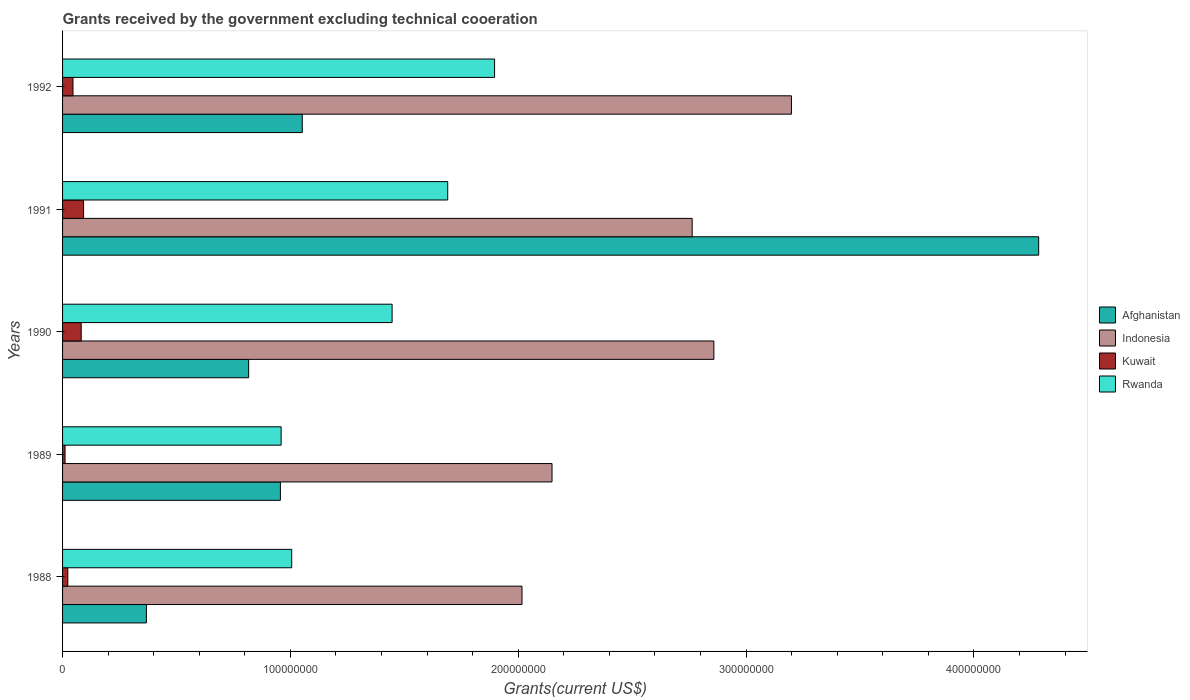How many groups of bars are there?
Your response must be concise. 5. Are the number of bars on each tick of the Y-axis equal?
Your response must be concise. Yes. How many bars are there on the 3rd tick from the top?
Give a very brief answer. 4. How many bars are there on the 4th tick from the bottom?
Keep it short and to the point. 4. What is the label of the 5th group of bars from the top?
Offer a terse response. 1988. What is the total grants received by the government in Rwanda in 1989?
Your answer should be very brief. 9.59e+07. Across all years, what is the maximum total grants received by the government in Kuwait?
Offer a terse response. 9.22e+06. Across all years, what is the minimum total grants received by the government in Afghanistan?
Make the answer very short. 3.68e+07. In which year was the total grants received by the government in Indonesia maximum?
Keep it short and to the point. 1992. In which year was the total grants received by the government in Afghanistan minimum?
Provide a short and direct response. 1988. What is the total total grants received by the government in Rwanda in the graph?
Offer a terse response. 7.00e+08. What is the difference between the total grants received by the government in Kuwait in 1988 and that in 1989?
Your response must be concise. 1.21e+06. What is the difference between the total grants received by the government in Kuwait in 1991 and the total grants received by the government in Rwanda in 1989?
Keep it short and to the point. -8.67e+07. What is the average total grants received by the government in Kuwait per year?
Provide a succinct answer. 5.07e+06. In the year 1990, what is the difference between the total grants received by the government in Afghanistan and total grants received by the government in Rwanda?
Give a very brief answer. -6.30e+07. In how many years, is the total grants received by the government in Afghanistan greater than 360000000 US$?
Offer a very short reply. 1. What is the ratio of the total grants received by the government in Rwanda in 1990 to that in 1992?
Offer a terse response. 0.76. Is the total grants received by the government in Kuwait in 1988 less than that in 1990?
Provide a short and direct response. Yes. What is the difference between the highest and the second highest total grants received by the government in Afghanistan?
Provide a succinct answer. 3.23e+08. What is the difference between the highest and the lowest total grants received by the government in Kuwait?
Your response must be concise. 8.13e+06. In how many years, is the total grants received by the government in Kuwait greater than the average total grants received by the government in Kuwait taken over all years?
Provide a succinct answer. 2. Is the sum of the total grants received by the government in Indonesia in 1990 and 1991 greater than the maximum total grants received by the government in Afghanistan across all years?
Give a very brief answer. Yes. What does the 2nd bar from the top in 1988 represents?
Your response must be concise. Kuwait. What does the 1st bar from the bottom in 1988 represents?
Give a very brief answer. Afghanistan. How many bars are there?
Provide a short and direct response. 20. Are all the bars in the graph horizontal?
Ensure brevity in your answer.  Yes. What is the difference between two consecutive major ticks on the X-axis?
Make the answer very short. 1.00e+08. Does the graph contain any zero values?
Your response must be concise. No. Does the graph contain grids?
Your answer should be compact. No. How many legend labels are there?
Offer a very short reply. 4. How are the legend labels stacked?
Keep it short and to the point. Vertical. What is the title of the graph?
Ensure brevity in your answer.  Grants received by the government excluding technical cooeration. Does "Yemen, Rep." appear as one of the legend labels in the graph?
Ensure brevity in your answer.  No. What is the label or title of the X-axis?
Your answer should be very brief. Grants(current US$). What is the label or title of the Y-axis?
Ensure brevity in your answer.  Years. What is the Grants(current US$) in Afghanistan in 1988?
Your response must be concise. 3.68e+07. What is the Grants(current US$) in Indonesia in 1988?
Offer a very short reply. 2.02e+08. What is the Grants(current US$) in Kuwait in 1988?
Provide a short and direct response. 2.30e+06. What is the Grants(current US$) of Rwanda in 1988?
Offer a very short reply. 1.01e+08. What is the Grants(current US$) in Afghanistan in 1989?
Make the answer very short. 9.56e+07. What is the Grants(current US$) of Indonesia in 1989?
Make the answer very short. 2.15e+08. What is the Grants(current US$) of Kuwait in 1989?
Make the answer very short. 1.09e+06. What is the Grants(current US$) in Rwanda in 1989?
Keep it short and to the point. 9.59e+07. What is the Grants(current US$) in Afghanistan in 1990?
Ensure brevity in your answer.  8.17e+07. What is the Grants(current US$) of Indonesia in 1990?
Keep it short and to the point. 2.86e+08. What is the Grants(current US$) in Kuwait in 1990?
Keep it short and to the point. 8.18e+06. What is the Grants(current US$) of Rwanda in 1990?
Make the answer very short. 1.45e+08. What is the Grants(current US$) in Afghanistan in 1991?
Provide a short and direct response. 4.28e+08. What is the Grants(current US$) of Indonesia in 1991?
Keep it short and to the point. 2.76e+08. What is the Grants(current US$) in Kuwait in 1991?
Provide a succinct answer. 9.22e+06. What is the Grants(current US$) of Rwanda in 1991?
Your response must be concise. 1.69e+08. What is the Grants(current US$) of Afghanistan in 1992?
Ensure brevity in your answer.  1.05e+08. What is the Grants(current US$) of Indonesia in 1992?
Your answer should be very brief. 3.20e+08. What is the Grants(current US$) in Kuwait in 1992?
Keep it short and to the point. 4.57e+06. What is the Grants(current US$) of Rwanda in 1992?
Keep it short and to the point. 1.90e+08. Across all years, what is the maximum Grants(current US$) in Afghanistan?
Give a very brief answer. 4.28e+08. Across all years, what is the maximum Grants(current US$) in Indonesia?
Provide a succinct answer. 3.20e+08. Across all years, what is the maximum Grants(current US$) of Kuwait?
Make the answer very short. 9.22e+06. Across all years, what is the maximum Grants(current US$) in Rwanda?
Your response must be concise. 1.90e+08. Across all years, what is the minimum Grants(current US$) of Afghanistan?
Your response must be concise. 3.68e+07. Across all years, what is the minimum Grants(current US$) in Indonesia?
Your answer should be very brief. 2.02e+08. Across all years, what is the minimum Grants(current US$) in Kuwait?
Your response must be concise. 1.09e+06. Across all years, what is the minimum Grants(current US$) of Rwanda?
Your response must be concise. 9.59e+07. What is the total Grants(current US$) of Afghanistan in the graph?
Give a very brief answer. 7.48e+08. What is the total Grants(current US$) of Indonesia in the graph?
Make the answer very short. 1.30e+09. What is the total Grants(current US$) of Kuwait in the graph?
Your answer should be very brief. 2.54e+07. What is the total Grants(current US$) in Rwanda in the graph?
Your response must be concise. 7.00e+08. What is the difference between the Grants(current US$) of Afghanistan in 1988 and that in 1989?
Offer a very short reply. -5.88e+07. What is the difference between the Grants(current US$) of Indonesia in 1988 and that in 1989?
Keep it short and to the point. -1.32e+07. What is the difference between the Grants(current US$) of Kuwait in 1988 and that in 1989?
Give a very brief answer. 1.21e+06. What is the difference between the Grants(current US$) of Rwanda in 1988 and that in 1989?
Your answer should be compact. 4.64e+06. What is the difference between the Grants(current US$) in Afghanistan in 1988 and that in 1990?
Offer a terse response. -4.49e+07. What is the difference between the Grants(current US$) of Indonesia in 1988 and that in 1990?
Your answer should be compact. -8.42e+07. What is the difference between the Grants(current US$) in Kuwait in 1988 and that in 1990?
Keep it short and to the point. -5.88e+06. What is the difference between the Grants(current US$) in Rwanda in 1988 and that in 1990?
Keep it short and to the point. -4.41e+07. What is the difference between the Grants(current US$) in Afghanistan in 1988 and that in 1991?
Your answer should be compact. -3.92e+08. What is the difference between the Grants(current US$) in Indonesia in 1988 and that in 1991?
Your answer should be very brief. -7.47e+07. What is the difference between the Grants(current US$) of Kuwait in 1988 and that in 1991?
Provide a short and direct response. -6.92e+06. What is the difference between the Grants(current US$) in Rwanda in 1988 and that in 1991?
Your response must be concise. -6.85e+07. What is the difference between the Grants(current US$) of Afghanistan in 1988 and that in 1992?
Provide a succinct answer. -6.84e+07. What is the difference between the Grants(current US$) of Indonesia in 1988 and that in 1992?
Provide a succinct answer. -1.18e+08. What is the difference between the Grants(current US$) of Kuwait in 1988 and that in 1992?
Provide a succinct answer. -2.27e+06. What is the difference between the Grants(current US$) in Rwanda in 1988 and that in 1992?
Your response must be concise. -8.90e+07. What is the difference between the Grants(current US$) of Afghanistan in 1989 and that in 1990?
Provide a short and direct response. 1.39e+07. What is the difference between the Grants(current US$) of Indonesia in 1989 and that in 1990?
Give a very brief answer. -7.10e+07. What is the difference between the Grants(current US$) in Kuwait in 1989 and that in 1990?
Offer a terse response. -7.09e+06. What is the difference between the Grants(current US$) in Rwanda in 1989 and that in 1990?
Offer a very short reply. -4.87e+07. What is the difference between the Grants(current US$) in Afghanistan in 1989 and that in 1991?
Your answer should be very brief. -3.33e+08. What is the difference between the Grants(current US$) of Indonesia in 1989 and that in 1991?
Provide a succinct answer. -6.15e+07. What is the difference between the Grants(current US$) of Kuwait in 1989 and that in 1991?
Provide a short and direct response. -8.13e+06. What is the difference between the Grants(current US$) in Rwanda in 1989 and that in 1991?
Make the answer very short. -7.31e+07. What is the difference between the Grants(current US$) of Afghanistan in 1989 and that in 1992?
Offer a terse response. -9.60e+06. What is the difference between the Grants(current US$) of Indonesia in 1989 and that in 1992?
Make the answer very short. -1.05e+08. What is the difference between the Grants(current US$) in Kuwait in 1989 and that in 1992?
Offer a terse response. -3.48e+06. What is the difference between the Grants(current US$) of Rwanda in 1989 and that in 1992?
Your answer should be compact. -9.37e+07. What is the difference between the Grants(current US$) of Afghanistan in 1990 and that in 1991?
Your answer should be very brief. -3.47e+08. What is the difference between the Grants(current US$) in Indonesia in 1990 and that in 1991?
Offer a very short reply. 9.52e+06. What is the difference between the Grants(current US$) of Kuwait in 1990 and that in 1991?
Your answer should be very brief. -1.04e+06. What is the difference between the Grants(current US$) in Rwanda in 1990 and that in 1991?
Provide a short and direct response. -2.44e+07. What is the difference between the Grants(current US$) in Afghanistan in 1990 and that in 1992?
Your answer should be very brief. -2.35e+07. What is the difference between the Grants(current US$) of Indonesia in 1990 and that in 1992?
Offer a terse response. -3.40e+07. What is the difference between the Grants(current US$) in Kuwait in 1990 and that in 1992?
Provide a succinct answer. 3.61e+06. What is the difference between the Grants(current US$) in Rwanda in 1990 and that in 1992?
Provide a succinct answer. -4.50e+07. What is the difference between the Grants(current US$) of Afghanistan in 1991 and that in 1992?
Offer a terse response. 3.23e+08. What is the difference between the Grants(current US$) of Indonesia in 1991 and that in 1992?
Your response must be concise. -4.36e+07. What is the difference between the Grants(current US$) in Kuwait in 1991 and that in 1992?
Provide a succinct answer. 4.65e+06. What is the difference between the Grants(current US$) of Rwanda in 1991 and that in 1992?
Provide a short and direct response. -2.06e+07. What is the difference between the Grants(current US$) of Afghanistan in 1988 and the Grants(current US$) of Indonesia in 1989?
Provide a short and direct response. -1.78e+08. What is the difference between the Grants(current US$) of Afghanistan in 1988 and the Grants(current US$) of Kuwait in 1989?
Give a very brief answer. 3.57e+07. What is the difference between the Grants(current US$) of Afghanistan in 1988 and the Grants(current US$) of Rwanda in 1989?
Make the answer very short. -5.91e+07. What is the difference between the Grants(current US$) of Indonesia in 1988 and the Grants(current US$) of Kuwait in 1989?
Provide a short and direct response. 2.01e+08. What is the difference between the Grants(current US$) in Indonesia in 1988 and the Grants(current US$) in Rwanda in 1989?
Provide a short and direct response. 1.06e+08. What is the difference between the Grants(current US$) of Kuwait in 1988 and the Grants(current US$) of Rwanda in 1989?
Your answer should be very brief. -9.36e+07. What is the difference between the Grants(current US$) of Afghanistan in 1988 and the Grants(current US$) of Indonesia in 1990?
Your response must be concise. -2.49e+08. What is the difference between the Grants(current US$) in Afghanistan in 1988 and the Grants(current US$) in Kuwait in 1990?
Keep it short and to the point. 2.86e+07. What is the difference between the Grants(current US$) in Afghanistan in 1988 and the Grants(current US$) in Rwanda in 1990?
Offer a terse response. -1.08e+08. What is the difference between the Grants(current US$) in Indonesia in 1988 and the Grants(current US$) in Kuwait in 1990?
Ensure brevity in your answer.  1.93e+08. What is the difference between the Grants(current US$) in Indonesia in 1988 and the Grants(current US$) in Rwanda in 1990?
Make the answer very short. 5.70e+07. What is the difference between the Grants(current US$) in Kuwait in 1988 and the Grants(current US$) in Rwanda in 1990?
Keep it short and to the point. -1.42e+08. What is the difference between the Grants(current US$) of Afghanistan in 1988 and the Grants(current US$) of Indonesia in 1991?
Your answer should be very brief. -2.40e+08. What is the difference between the Grants(current US$) in Afghanistan in 1988 and the Grants(current US$) in Kuwait in 1991?
Keep it short and to the point. 2.76e+07. What is the difference between the Grants(current US$) in Afghanistan in 1988 and the Grants(current US$) in Rwanda in 1991?
Your answer should be compact. -1.32e+08. What is the difference between the Grants(current US$) of Indonesia in 1988 and the Grants(current US$) of Kuwait in 1991?
Provide a short and direct response. 1.92e+08. What is the difference between the Grants(current US$) in Indonesia in 1988 and the Grants(current US$) in Rwanda in 1991?
Your answer should be very brief. 3.26e+07. What is the difference between the Grants(current US$) of Kuwait in 1988 and the Grants(current US$) of Rwanda in 1991?
Give a very brief answer. -1.67e+08. What is the difference between the Grants(current US$) in Afghanistan in 1988 and the Grants(current US$) in Indonesia in 1992?
Offer a very short reply. -2.83e+08. What is the difference between the Grants(current US$) in Afghanistan in 1988 and the Grants(current US$) in Kuwait in 1992?
Keep it short and to the point. 3.22e+07. What is the difference between the Grants(current US$) in Afghanistan in 1988 and the Grants(current US$) in Rwanda in 1992?
Your answer should be compact. -1.53e+08. What is the difference between the Grants(current US$) in Indonesia in 1988 and the Grants(current US$) in Kuwait in 1992?
Offer a terse response. 1.97e+08. What is the difference between the Grants(current US$) of Indonesia in 1988 and the Grants(current US$) of Rwanda in 1992?
Your answer should be very brief. 1.20e+07. What is the difference between the Grants(current US$) in Kuwait in 1988 and the Grants(current US$) in Rwanda in 1992?
Your answer should be compact. -1.87e+08. What is the difference between the Grants(current US$) of Afghanistan in 1989 and the Grants(current US$) of Indonesia in 1990?
Your response must be concise. -1.90e+08. What is the difference between the Grants(current US$) of Afghanistan in 1989 and the Grants(current US$) of Kuwait in 1990?
Your response must be concise. 8.74e+07. What is the difference between the Grants(current US$) of Afghanistan in 1989 and the Grants(current US$) of Rwanda in 1990?
Ensure brevity in your answer.  -4.90e+07. What is the difference between the Grants(current US$) in Indonesia in 1989 and the Grants(current US$) in Kuwait in 1990?
Provide a short and direct response. 2.07e+08. What is the difference between the Grants(current US$) of Indonesia in 1989 and the Grants(current US$) of Rwanda in 1990?
Ensure brevity in your answer.  7.02e+07. What is the difference between the Grants(current US$) in Kuwait in 1989 and the Grants(current US$) in Rwanda in 1990?
Make the answer very short. -1.44e+08. What is the difference between the Grants(current US$) of Afghanistan in 1989 and the Grants(current US$) of Indonesia in 1991?
Your answer should be very brief. -1.81e+08. What is the difference between the Grants(current US$) in Afghanistan in 1989 and the Grants(current US$) in Kuwait in 1991?
Make the answer very short. 8.64e+07. What is the difference between the Grants(current US$) in Afghanistan in 1989 and the Grants(current US$) in Rwanda in 1991?
Your answer should be compact. -7.34e+07. What is the difference between the Grants(current US$) in Indonesia in 1989 and the Grants(current US$) in Kuwait in 1991?
Give a very brief answer. 2.06e+08. What is the difference between the Grants(current US$) of Indonesia in 1989 and the Grants(current US$) of Rwanda in 1991?
Offer a terse response. 4.58e+07. What is the difference between the Grants(current US$) of Kuwait in 1989 and the Grants(current US$) of Rwanda in 1991?
Offer a terse response. -1.68e+08. What is the difference between the Grants(current US$) of Afghanistan in 1989 and the Grants(current US$) of Indonesia in 1992?
Your answer should be very brief. -2.24e+08. What is the difference between the Grants(current US$) in Afghanistan in 1989 and the Grants(current US$) in Kuwait in 1992?
Give a very brief answer. 9.10e+07. What is the difference between the Grants(current US$) in Afghanistan in 1989 and the Grants(current US$) in Rwanda in 1992?
Your answer should be compact. -9.40e+07. What is the difference between the Grants(current US$) of Indonesia in 1989 and the Grants(current US$) of Kuwait in 1992?
Ensure brevity in your answer.  2.10e+08. What is the difference between the Grants(current US$) in Indonesia in 1989 and the Grants(current US$) in Rwanda in 1992?
Keep it short and to the point. 2.52e+07. What is the difference between the Grants(current US$) in Kuwait in 1989 and the Grants(current US$) in Rwanda in 1992?
Keep it short and to the point. -1.89e+08. What is the difference between the Grants(current US$) in Afghanistan in 1990 and the Grants(current US$) in Indonesia in 1991?
Make the answer very short. -1.95e+08. What is the difference between the Grants(current US$) in Afghanistan in 1990 and the Grants(current US$) in Kuwait in 1991?
Offer a terse response. 7.25e+07. What is the difference between the Grants(current US$) of Afghanistan in 1990 and the Grants(current US$) of Rwanda in 1991?
Ensure brevity in your answer.  -8.74e+07. What is the difference between the Grants(current US$) of Indonesia in 1990 and the Grants(current US$) of Kuwait in 1991?
Offer a very short reply. 2.77e+08. What is the difference between the Grants(current US$) of Indonesia in 1990 and the Grants(current US$) of Rwanda in 1991?
Your answer should be compact. 1.17e+08. What is the difference between the Grants(current US$) in Kuwait in 1990 and the Grants(current US$) in Rwanda in 1991?
Provide a short and direct response. -1.61e+08. What is the difference between the Grants(current US$) in Afghanistan in 1990 and the Grants(current US$) in Indonesia in 1992?
Your answer should be compact. -2.38e+08. What is the difference between the Grants(current US$) in Afghanistan in 1990 and the Grants(current US$) in Kuwait in 1992?
Provide a short and direct response. 7.71e+07. What is the difference between the Grants(current US$) of Afghanistan in 1990 and the Grants(current US$) of Rwanda in 1992?
Provide a short and direct response. -1.08e+08. What is the difference between the Grants(current US$) in Indonesia in 1990 and the Grants(current US$) in Kuwait in 1992?
Your answer should be very brief. 2.81e+08. What is the difference between the Grants(current US$) of Indonesia in 1990 and the Grants(current US$) of Rwanda in 1992?
Your response must be concise. 9.62e+07. What is the difference between the Grants(current US$) of Kuwait in 1990 and the Grants(current US$) of Rwanda in 1992?
Your answer should be very brief. -1.81e+08. What is the difference between the Grants(current US$) of Afghanistan in 1991 and the Grants(current US$) of Indonesia in 1992?
Provide a short and direct response. 1.09e+08. What is the difference between the Grants(current US$) in Afghanistan in 1991 and the Grants(current US$) in Kuwait in 1992?
Offer a very short reply. 4.24e+08. What is the difference between the Grants(current US$) of Afghanistan in 1991 and the Grants(current US$) of Rwanda in 1992?
Ensure brevity in your answer.  2.39e+08. What is the difference between the Grants(current US$) in Indonesia in 1991 and the Grants(current US$) in Kuwait in 1992?
Your answer should be compact. 2.72e+08. What is the difference between the Grants(current US$) in Indonesia in 1991 and the Grants(current US$) in Rwanda in 1992?
Make the answer very short. 8.67e+07. What is the difference between the Grants(current US$) in Kuwait in 1991 and the Grants(current US$) in Rwanda in 1992?
Make the answer very short. -1.80e+08. What is the average Grants(current US$) of Afghanistan per year?
Your answer should be very brief. 1.50e+08. What is the average Grants(current US$) of Indonesia per year?
Give a very brief answer. 2.60e+08. What is the average Grants(current US$) of Kuwait per year?
Offer a terse response. 5.07e+06. What is the average Grants(current US$) in Rwanda per year?
Your response must be concise. 1.40e+08. In the year 1988, what is the difference between the Grants(current US$) of Afghanistan and Grants(current US$) of Indonesia?
Keep it short and to the point. -1.65e+08. In the year 1988, what is the difference between the Grants(current US$) in Afghanistan and Grants(current US$) in Kuwait?
Keep it short and to the point. 3.45e+07. In the year 1988, what is the difference between the Grants(current US$) in Afghanistan and Grants(current US$) in Rwanda?
Offer a terse response. -6.38e+07. In the year 1988, what is the difference between the Grants(current US$) in Indonesia and Grants(current US$) in Kuwait?
Your response must be concise. 1.99e+08. In the year 1988, what is the difference between the Grants(current US$) of Indonesia and Grants(current US$) of Rwanda?
Your response must be concise. 1.01e+08. In the year 1988, what is the difference between the Grants(current US$) of Kuwait and Grants(current US$) of Rwanda?
Give a very brief answer. -9.83e+07. In the year 1989, what is the difference between the Grants(current US$) in Afghanistan and Grants(current US$) in Indonesia?
Make the answer very short. -1.19e+08. In the year 1989, what is the difference between the Grants(current US$) in Afghanistan and Grants(current US$) in Kuwait?
Make the answer very short. 9.45e+07. In the year 1989, what is the difference between the Grants(current US$) in Afghanistan and Grants(current US$) in Rwanda?
Keep it short and to the point. -3.20e+05. In the year 1989, what is the difference between the Grants(current US$) of Indonesia and Grants(current US$) of Kuwait?
Make the answer very short. 2.14e+08. In the year 1989, what is the difference between the Grants(current US$) of Indonesia and Grants(current US$) of Rwanda?
Offer a terse response. 1.19e+08. In the year 1989, what is the difference between the Grants(current US$) in Kuwait and Grants(current US$) in Rwanda?
Offer a very short reply. -9.48e+07. In the year 1990, what is the difference between the Grants(current US$) of Afghanistan and Grants(current US$) of Indonesia?
Ensure brevity in your answer.  -2.04e+08. In the year 1990, what is the difference between the Grants(current US$) in Afghanistan and Grants(current US$) in Kuwait?
Your response must be concise. 7.35e+07. In the year 1990, what is the difference between the Grants(current US$) in Afghanistan and Grants(current US$) in Rwanda?
Your response must be concise. -6.30e+07. In the year 1990, what is the difference between the Grants(current US$) in Indonesia and Grants(current US$) in Kuwait?
Your response must be concise. 2.78e+08. In the year 1990, what is the difference between the Grants(current US$) of Indonesia and Grants(current US$) of Rwanda?
Provide a succinct answer. 1.41e+08. In the year 1990, what is the difference between the Grants(current US$) of Kuwait and Grants(current US$) of Rwanda?
Ensure brevity in your answer.  -1.36e+08. In the year 1991, what is the difference between the Grants(current US$) of Afghanistan and Grants(current US$) of Indonesia?
Offer a very short reply. 1.52e+08. In the year 1991, what is the difference between the Grants(current US$) in Afghanistan and Grants(current US$) in Kuwait?
Your response must be concise. 4.19e+08. In the year 1991, what is the difference between the Grants(current US$) in Afghanistan and Grants(current US$) in Rwanda?
Give a very brief answer. 2.59e+08. In the year 1991, what is the difference between the Grants(current US$) of Indonesia and Grants(current US$) of Kuwait?
Ensure brevity in your answer.  2.67e+08. In the year 1991, what is the difference between the Grants(current US$) in Indonesia and Grants(current US$) in Rwanda?
Offer a terse response. 1.07e+08. In the year 1991, what is the difference between the Grants(current US$) in Kuwait and Grants(current US$) in Rwanda?
Offer a very short reply. -1.60e+08. In the year 1992, what is the difference between the Grants(current US$) of Afghanistan and Grants(current US$) of Indonesia?
Make the answer very short. -2.15e+08. In the year 1992, what is the difference between the Grants(current US$) in Afghanistan and Grants(current US$) in Kuwait?
Make the answer very short. 1.01e+08. In the year 1992, what is the difference between the Grants(current US$) of Afghanistan and Grants(current US$) of Rwanda?
Your answer should be very brief. -8.44e+07. In the year 1992, what is the difference between the Grants(current US$) of Indonesia and Grants(current US$) of Kuwait?
Make the answer very short. 3.15e+08. In the year 1992, what is the difference between the Grants(current US$) in Indonesia and Grants(current US$) in Rwanda?
Provide a succinct answer. 1.30e+08. In the year 1992, what is the difference between the Grants(current US$) of Kuwait and Grants(current US$) of Rwanda?
Make the answer very short. -1.85e+08. What is the ratio of the Grants(current US$) in Afghanistan in 1988 to that in 1989?
Ensure brevity in your answer.  0.38. What is the ratio of the Grants(current US$) of Indonesia in 1988 to that in 1989?
Offer a terse response. 0.94. What is the ratio of the Grants(current US$) of Kuwait in 1988 to that in 1989?
Keep it short and to the point. 2.11. What is the ratio of the Grants(current US$) of Rwanda in 1988 to that in 1989?
Ensure brevity in your answer.  1.05. What is the ratio of the Grants(current US$) in Afghanistan in 1988 to that in 1990?
Offer a very short reply. 0.45. What is the ratio of the Grants(current US$) of Indonesia in 1988 to that in 1990?
Provide a short and direct response. 0.71. What is the ratio of the Grants(current US$) in Kuwait in 1988 to that in 1990?
Ensure brevity in your answer.  0.28. What is the ratio of the Grants(current US$) in Rwanda in 1988 to that in 1990?
Your response must be concise. 0.7. What is the ratio of the Grants(current US$) in Afghanistan in 1988 to that in 1991?
Your answer should be compact. 0.09. What is the ratio of the Grants(current US$) of Indonesia in 1988 to that in 1991?
Your answer should be compact. 0.73. What is the ratio of the Grants(current US$) in Kuwait in 1988 to that in 1991?
Your response must be concise. 0.25. What is the ratio of the Grants(current US$) in Rwanda in 1988 to that in 1991?
Your answer should be very brief. 0.59. What is the ratio of the Grants(current US$) of Afghanistan in 1988 to that in 1992?
Your answer should be very brief. 0.35. What is the ratio of the Grants(current US$) of Indonesia in 1988 to that in 1992?
Your answer should be very brief. 0.63. What is the ratio of the Grants(current US$) of Kuwait in 1988 to that in 1992?
Your answer should be compact. 0.5. What is the ratio of the Grants(current US$) in Rwanda in 1988 to that in 1992?
Keep it short and to the point. 0.53. What is the ratio of the Grants(current US$) of Afghanistan in 1989 to that in 1990?
Provide a succinct answer. 1.17. What is the ratio of the Grants(current US$) of Indonesia in 1989 to that in 1990?
Make the answer very short. 0.75. What is the ratio of the Grants(current US$) in Kuwait in 1989 to that in 1990?
Offer a terse response. 0.13. What is the ratio of the Grants(current US$) in Rwanda in 1989 to that in 1990?
Your answer should be compact. 0.66. What is the ratio of the Grants(current US$) of Afghanistan in 1989 to that in 1991?
Keep it short and to the point. 0.22. What is the ratio of the Grants(current US$) of Indonesia in 1989 to that in 1991?
Provide a short and direct response. 0.78. What is the ratio of the Grants(current US$) of Kuwait in 1989 to that in 1991?
Provide a short and direct response. 0.12. What is the ratio of the Grants(current US$) in Rwanda in 1989 to that in 1991?
Offer a terse response. 0.57. What is the ratio of the Grants(current US$) in Afghanistan in 1989 to that in 1992?
Your response must be concise. 0.91. What is the ratio of the Grants(current US$) in Indonesia in 1989 to that in 1992?
Make the answer very short. 0.67. What is the ratio of the Grants(current US$) in Kuwait in 1989 to that in 1992?
Your response must be concise. 0.24. What is the ratio of the Grants(current US$) of Rwanda in 1989 to that in 1992?
Give a very brief answer. 0.51. What is the ratio of the Grants(current US$) in Afghanistan in 1990 to that in 1991?
Your answer should be compact. 0.19. What is the ratio of the Grants(current US$) in Indonesia in 1990 to that in 1991?
Offer a very short reply. 1.03. What is the ratio of the Grants(current US$) of Kuwait in 1990 to that in 1991?
Provide a short and direct response. 0.89. What is the ratio of the Grants(current US$) in Rwanda in 1990 to that in 1991?
Offer a terse response. 0.86. What is the ratio of the Grants(current US$) in Afghanistan in 1990 to that in 1992?
Give a very brief answer. 0.78. What is the ratio of the Grants(current US$) of Indonesia in 1990 to that in 1992?
Keep it short and to the point. 0.89. What is the ratio of the Grants(current US$) in Kuwait in 1990 to that in 1992?
Offer a terse response. 1.79. What is the ratio of the Grants(current US$) in Rwanda in 1990 to that in 1992?
Provide a succinct answer. 0.76. What is the ratio of the Grants(current US$) of Afghanistan in 1991 to that in 1992?
Provide a succinct answer. 4.07. What is the ratio of the Grants(current US$) of Indonesia in 1991 to that in 1992?
Your answer should be compact. 0.86. What is the ratio of the Grants(current US$) in Kuwait in 1991 to that in 1992?
Your answer should be very brief. 2.02. What is the ratio of the Grants(current US$) in Rwanda in 1991 to that in 1992?
Offer a very short reply. 0.89. What is the difference between the highest and the second highest Grants(current US$) of Afghanistan?
Offer a terse response. 3.23e+08. What is the difference between the highest and the second highest Grants(current US$) of Indonesia?
Make the answer very short. 3.40e+07. What is the difference between the highest and the second highest Grants(current US$) in Kuwait?
Make the answer very short. 1.04e+06. What is the difference between the highest and the second highest Grants(current US$) of Rwanda?
Your answer should be compact. 2.06e+07. What is the difference between the highest and the lowest Grants(current US$) of Afghanistan?
Keep it short and to the point. 3.92e+08. What is the difference between the highest and the lowest Grants(current US$) in Indonesia?
Your response must be concise. 1.18e+08. What is the difference between the highest and the lowest Grants(current US$) in Kuwait?
Make the answer very short. 8.13e+06. What is the difference between the highest and the lowest Grants(current US$) in Rwanda?
Give a very brief answer. 9.37e+07. 